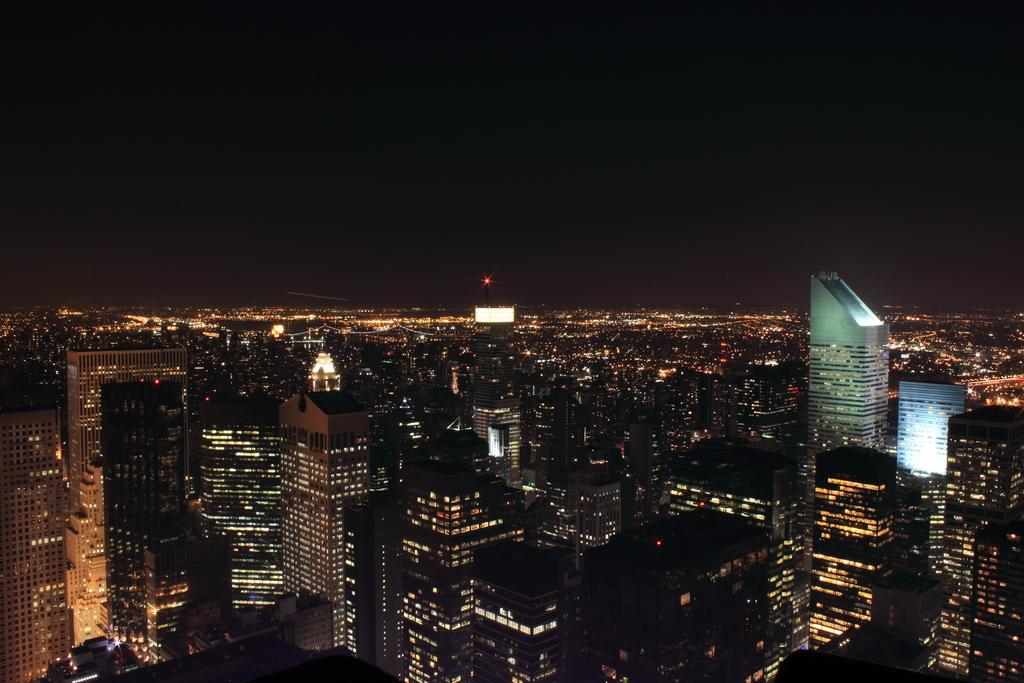What type of structures can be seen in the image? There are buildings in the image. What can be seen illuminating the scene in the image? There are lights visible in the image. What part of the natural environment is visible in the image? The sky is visible in the image. How many knots are tied on the top of the building in the image? There are no knots present on the top of the building in the image. What type of push can be seen being applied to the building in the image? There is no push being applied to the building in the image. 